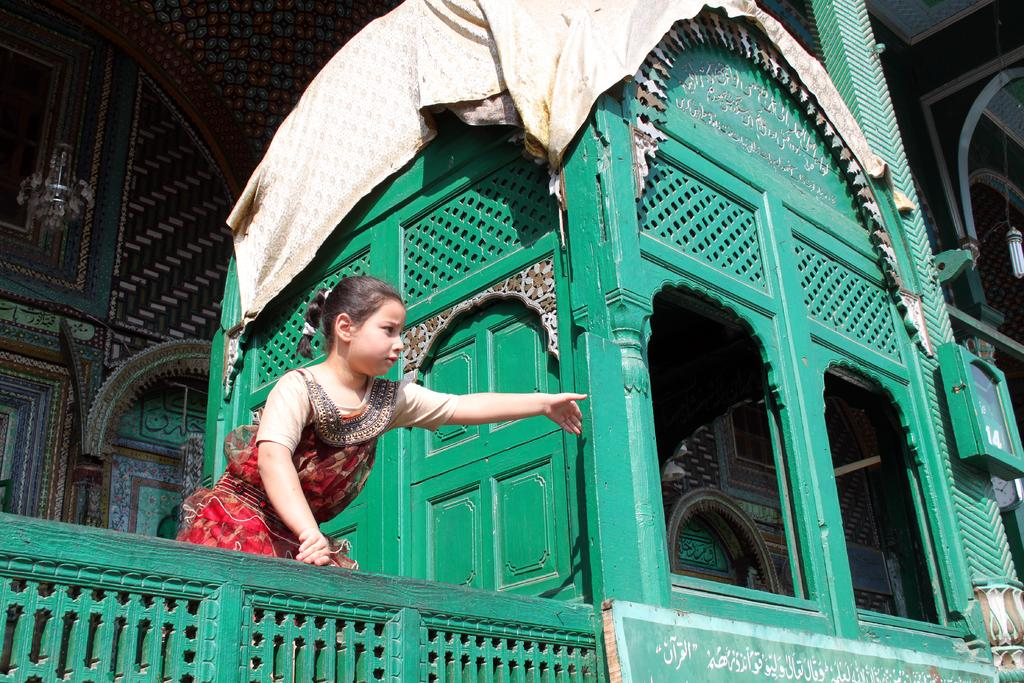What type of structure is visible in the image? There is a building in the image. Who or what else can be seen in the image? There is a girl in the image. What is the girl holding or wearing? Clothes are present in the image. Can you describe the lighting in the image? There is a light on the right side of the image. What type of metal is used to make the girl's feet in the image? The girl's feet are not made of metal, and there is no indication of any metal objects in the image. 